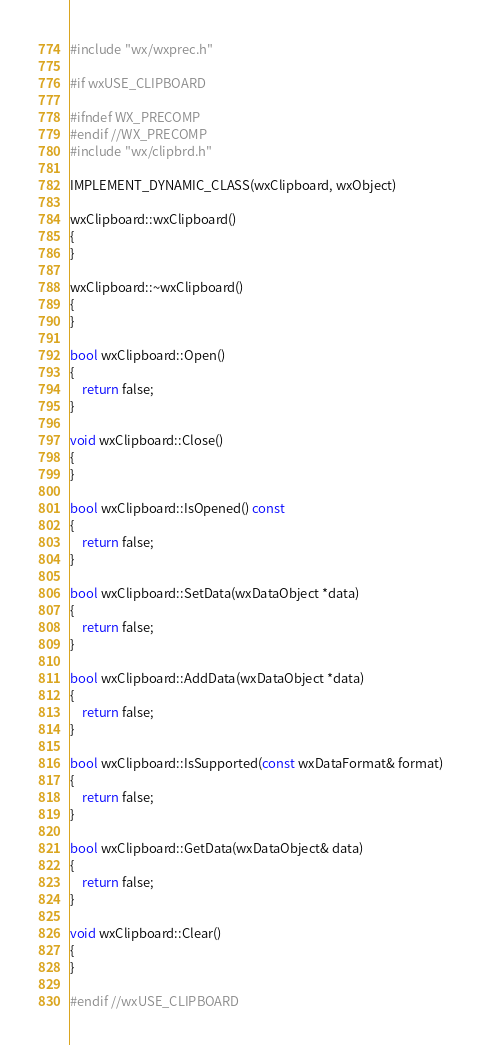Convert code to text. <code><loc_0><loc_0><loc_500><loc_500><_ObjectiveC_>
#include "wx/wxprec.h"

#if wxUSE_CLIPBOARD

#ifndef WX_PRECOMP
#endif //WX_PRECOMP
#include "wx/clipbrd.h"

IMPLEMENT_DYNAMIC_CLASS(wxClipboard, wxObject)

wxClipboard::wxClipboard()
{
}

wxClipboard::~wxClipboard()
{
}

bool wxClipboard::Open()
{
    return false;
}

void wxClipboard::Close()
{
}

bool wxClipboard::IsOpened() const
{
    return false;
}

bool wxClipboard::SetData(wxDataObject *data)
{
    return false;
}

bool wxClipboard::AddData(wxDataObject *data)
{
    return false;
}

bool wxClipboard::IsSupported(const wxDataFormat& format)
{
    return false;
}

bool wxClipboard::GetData(wxDataObject& data)
{
    return false;
}

void wxClipboard::Clear()
{
}

#endif //wxUSE_CLIPBOARD
</code> 